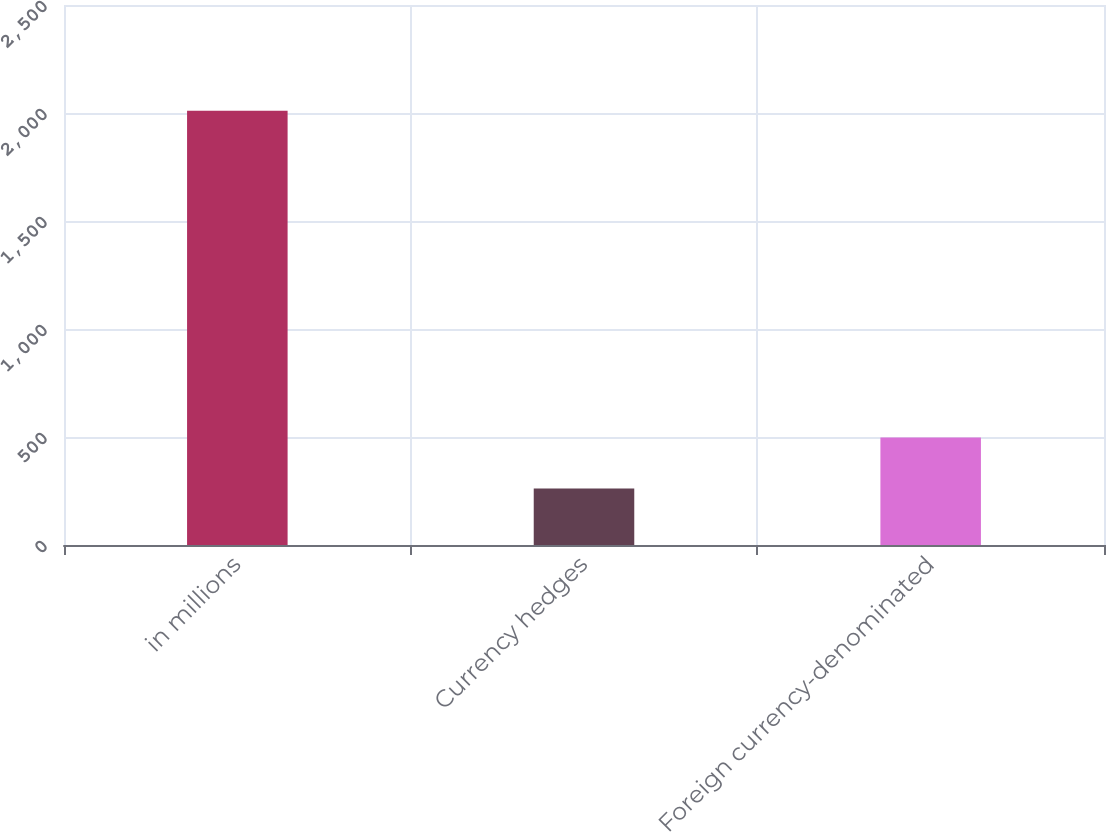<chart> <loc_0><loc_0><loc_500><loc_500><bar_chart><fcel>in millions<fcel>Currency hedges<fcel>Foreign currency-denominated<nl><fcel>2010<fcel>261<fcel>498<nl></chart> 